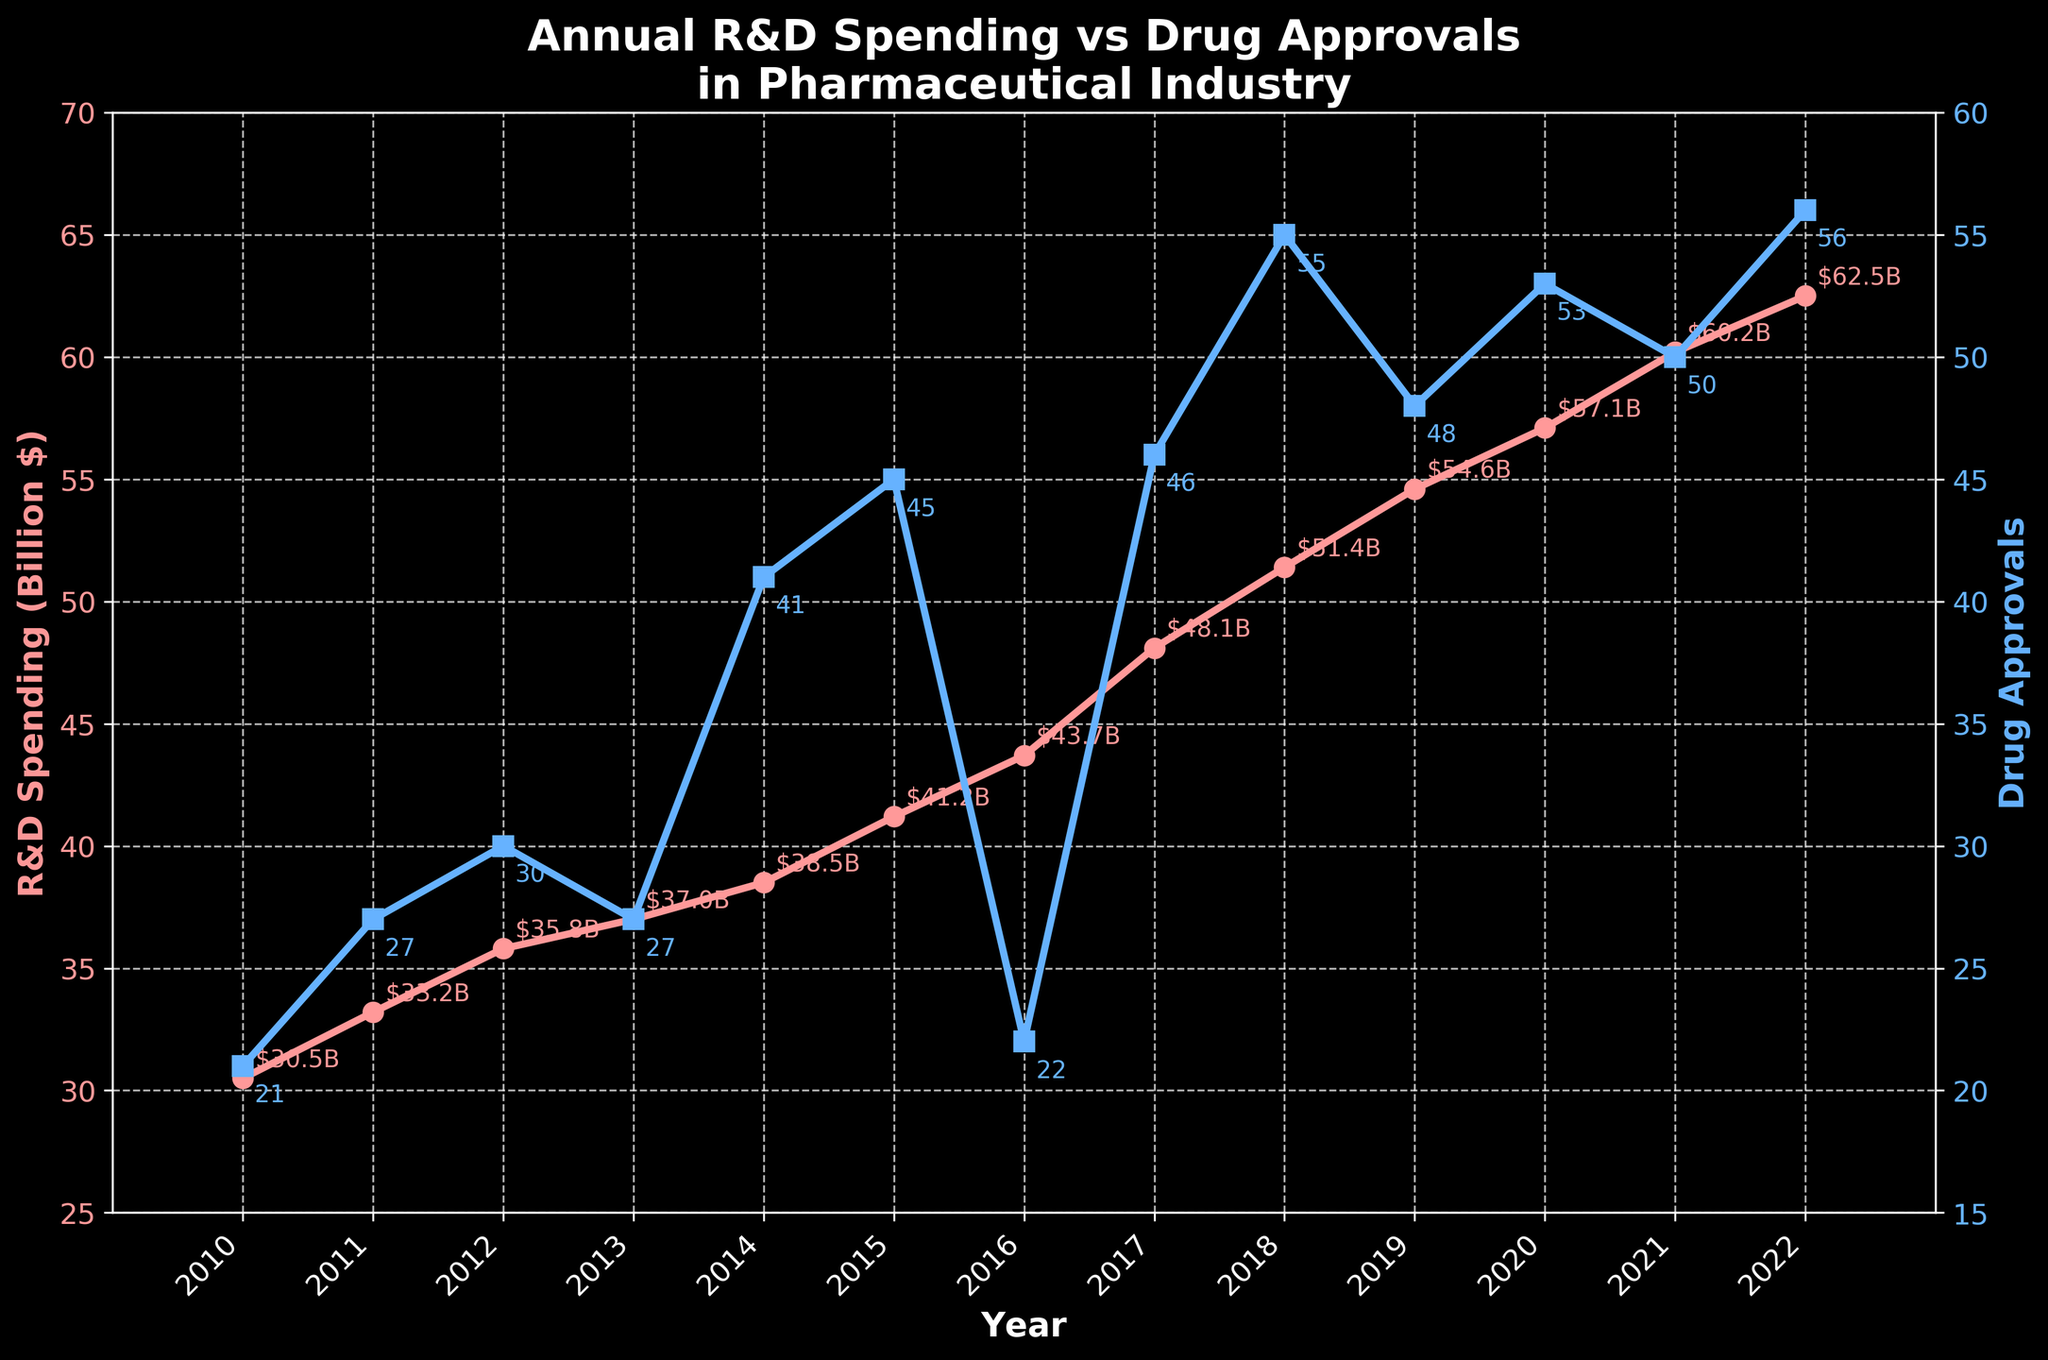What is the title of the figure? The title is displayed at the top of the plot, and it provides a summary of what the figure is about. In this case, it reads "Annual R&D Spending vs Drug Approvals in Pharmaceutical Industry".
Answer: Annual R&D Spending vs Drug Approvals in Pharmaceutical Industry What color is used to represent R&D Spending? The color of the line representing R&D Spending is distinctly identified in the plot. It is a pinkish color.
Answer: Pink How many drug approvals were there in 2018? From the plot, locate the data point corresponding to the year 2018 on the axis. The number of drug approvals, marked by square markers, is annotated as 55.
Answer: 55 In which year did R&D Spending first exceed 50 billion dollars? Examine the plot for the R&D Spending curve. The curve crosses the 50 billion dollar mark for the first time in 2018.
Answer: 2018 What is the average number of drug approvals from 2010 to 2015? Count the number of years between 2010 to 2015 (inclusive), which is 6 years. Add up the drug approvals in each of these years (21+27+30+27+41+45) and divide by 6. This gives (191/6), which equals approximately 31.83.
Answer: 31.83 Did R&D Spending increase, decrease, or stay the same from 2021 to 2022? By comparing the values for R&D Spending between the years 2021 and 2022, it is clear that it increased from 60.2 billion dollars to 62.5 billion dollars.
Answer: Increased Which year saw the highest number of drug approvals and what was the count? By reviewing the drug approval data points annotated on the plot, 2018 shows the highest number of drug approvals, which is 55.
Answer: 2018, 55 Was there any year where R&D Spending decreased compared to its previous year? If yes, which year? Examine the R&D Spending values year over year to detect any decreases. None of the years show a decrease in R&D Spending compared to the previous year.
Answer: No What’s the difference in R&D Spending between 2010 and 2022? Subtract the R&D Spending of 2010 from that of 2022. The calculation is 62.5 - 30.5, which equals 32 billion dollars.
Answer: 32 billion dollars Which year had a higher count of drug approvals, 2016 or 2020? Compare the number of drug approvals between 2016 and 2020. There were 22 approvals in 2016 and 53 in 2020, so 2020 had higher drug approvals.
Answer: 2020 